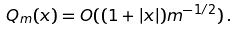<formula> <loc_0><loc_0><loc_500><loc_500>Q _ { m } ( x ) = O ( ( 1 + | x | ) m ^ { - 1 / 2 } ) \, .</formula> 